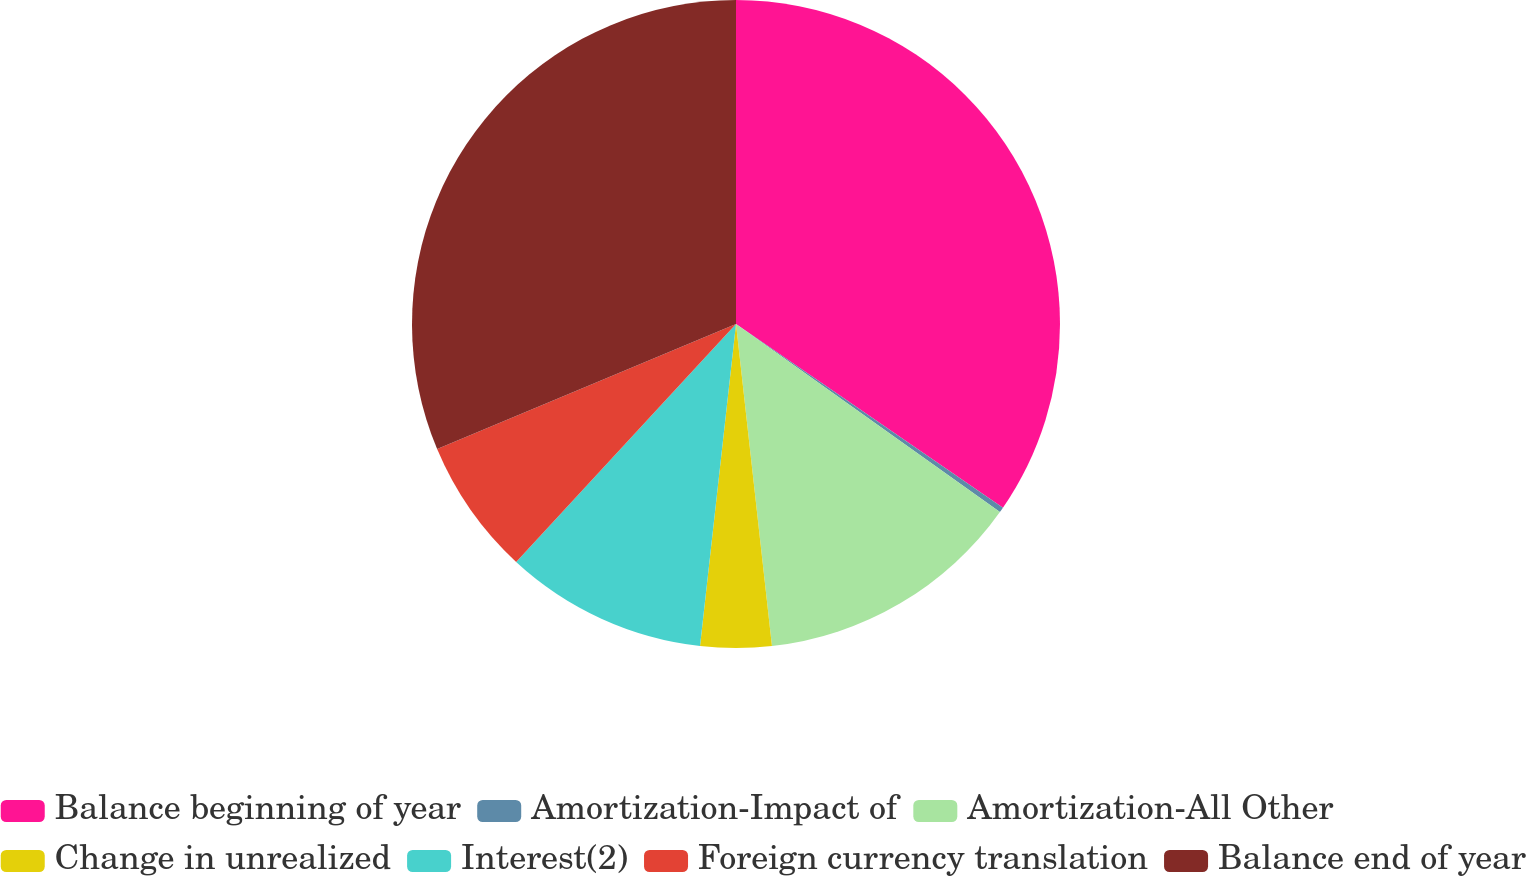<chart> <loc_0><loc_0><loc_500><loc_500><pie_chart><fcel>Balance beginning of year<fcel>Amortization-Impact of<fcel>Amortization-All Other<fcel>Change in unrealized<fcel>Interest(2)<fcel>Foreign currency translation<fcel>Balance end of year<nl><fcel>34.59%<fcel>0.26%<fcel>13.38%<fcel>3.54%<fcel>10.1%<fcel>6.82%<fcel>31.31%<nl></chart> 